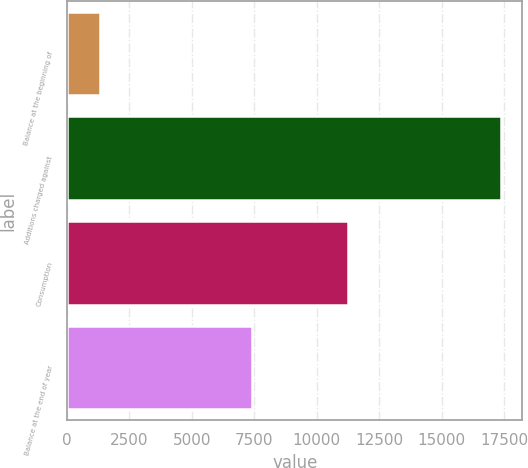Convert chart to OTSL. <chart><loc_0><loc_0><loc_500><loc_500><bar_chart><fcel>Balance at the beginning of<fcel>Additions charged against<fcel>Consumption<fcel>Balance at the end of year<nl><fcel>1317<fcel>17371<fcel>11265<fcel>7423<nl></chart> 